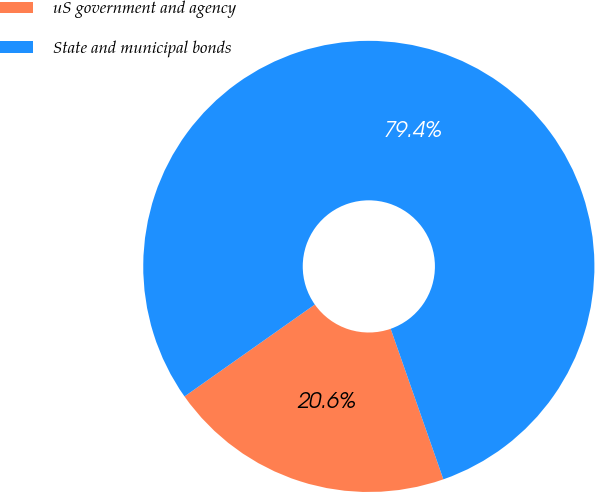<chart> <loc_0><loc_0><loc_500><loc_500><pie_chart><fcel>uS government and agency<fcel>State and municipal bonds<nl><fcel>20.58%<fcel>79.42%<nl></chart> 